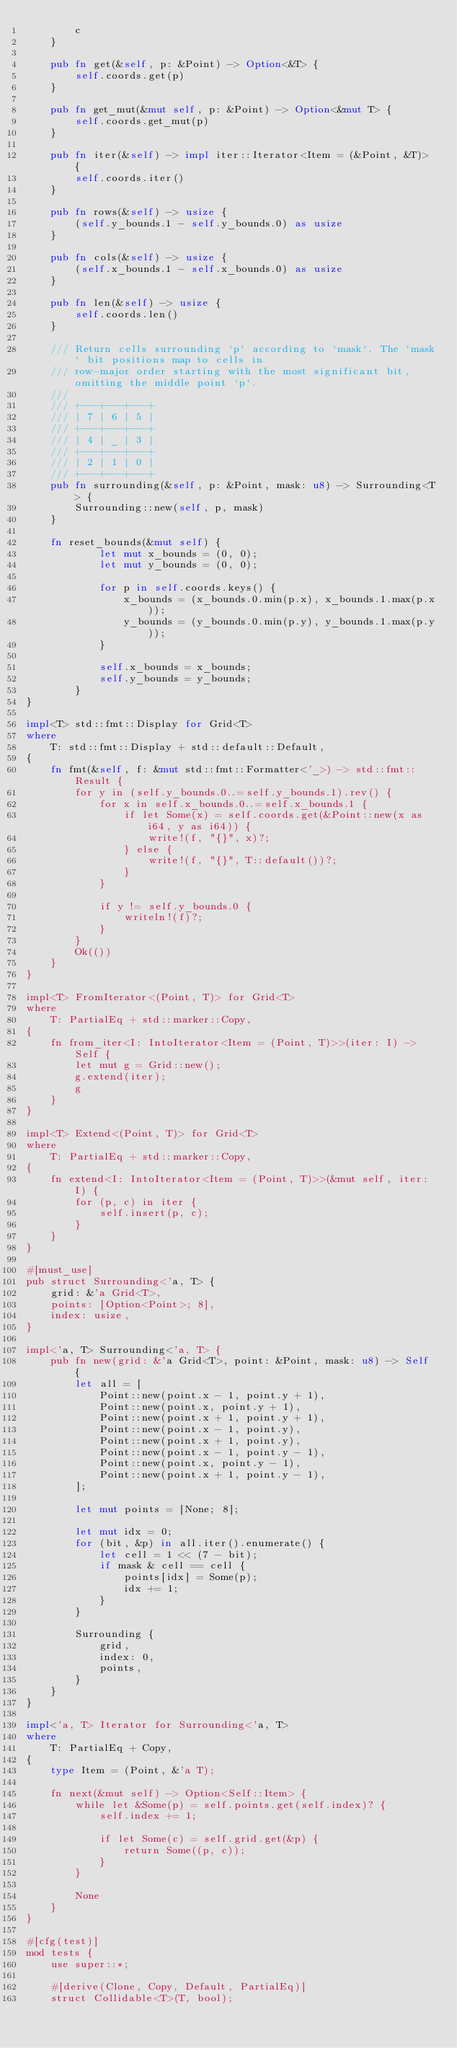<code> <loc_0><loc_0><loc_500><loc_500><_Rust_>        c
    }

    pub fn get(&self, p: &Point) -> Option<&T> {
        self.coords.get(p)
    }

    pub fn get_mut(&mut self, p: &Point) -> Option<&mut T> {
        self.coords.get_mut(p)
    }

    pub fn iter(&self) -> impl iter::Iterator<Item = (&Point, &T)> {
        self.coords.iter()
    }

    pub fn rows(&self) -> usize {
        (self.y_bounds.1 - self.y_bounds.0) as usize
    }

    pub fn cols(&self) -> usize {
        (self.x_bounds.1 - self.x_bounds.0) as usize
    }

    pub fn len(&self) -> usize {
        self.coords.len()
    }

    /// Return cells surrounding `p` according to `mask`. The `mask` bit positions map to cells in
    /// row-major order starting with the most significant bit, omitting the middle point `p`.
    ///
    /// +---+---+---+
    /// | 7 | 6 | 5 |
    /// +---+---+---+
    /// | 4 | _ | 3 |
    /// +---+---+---+
    /// | 2 | 1 | 0 |
    /// +---+---+---+
    pub fn surrounding(&self, p: &Point, mask: u8) -> Surrounding<T> {
        Surrounding::new(self, p, mask)
    }

    fn reset_bounds(&mut self) {
            let mut x_bounds = (0, 0);
            let mut y_bounds = (0, 0);

            for p in self.coords.keys() {
                x_bounds = (x_bounds.0.min(p.x), x_bounds.1.max(p.x));
                y_bounds = (y_bounds.0.min(p.y), y_bounds.1.max(p.y));
            }

            self.x_bounds = x_bounds;
            self.y_bounds = y_bounds;
        }
}

impl<T> std::fmt::Display for Grid<T>
where
    T: std::fmt::Display + std::default::Default,
{
    fn fmt(&self, f: &mut std::fmt::Formatter<'_>) -> std::fmt::Result {
        for y in (self.y_bounds.0..=self.y_bounds.1).rev() {
            for x in self.x_bounds.0..=self.x_bounds.1 {
                if let Some(x) = self.coords.get(&Point::new(x as i64, y as i64)) {
                    write!(f, "{}", x)?;
                } else {
                    write!(f, "{}", T::default())?;
                }
            }

            if y != self.y_bounds.0 {
                writeln!(f)?;
            }
        }
        Ok(())
    }
}

impl<T> FromIterator<(Point, T)> for Grid<T>
where
    T: PartialEq + std::marker::Copy,
{
    fn from_iter<I: IntoIterator<Item = (Point, T)>>(iter: I) -> Self {
        let mut g = Grid::new();
        g.extend(iter);
        g
    }
}

impl<T> Extend<(Point, T)> for Grid<T>
where
    T: PartialEq + std::marker::Copy,
{
    fn extend<I: IntoIterator<Item = (Point, T)>>(&mut self, iter: I) {
        for (p, c) in iter {
            self.insert(p, c);
        }
    }
}

#[must_use]
pub struct Surrounding<'a, T> {
    grid: &'a Grid<T>,
    points: [Option<Point>; 8],
    index: usize,
}

impl<'a, T> Surrounding<'a, T> {
    pub fn new(grid: &'a Grid<T>, point: &Point, mask: u8) -> Self {
        let all = [
            Point::new(point.x - 1, point.y + 1),
            Point::new(point.x, point.y + 1),
            Point::new(point.x + 1, point.y + 1),
            Point::new(point.x - 1, point.y),
            Point::new(point.x + 1, point.y),
            Point::new(point.x - 1, point.y - 1),
            Point::new(point.x, point.y - 1),
            Point::new(point.x + 1, point.y - 1),
        ];

        let mut points = [None; 8];

        let mut idx = 0;
        for (bit, &p) in all.iter().enumerate() {
            let cell = 1 << (7 - bit);
            if mask & cell == cell {
                points[idx] = Some(p);
                idx += 1;
            }
        }

        Surrounding {
            grid,
            index: 0,
            points,
        }
    }
}

impl<'a, T> Iterator for Surrounding<'a, T>
where
    T: PartialEq + Copy,
{
    type Item = (Point, &'a T);

    fn next(&mut self) -> Option<Self::Item> {
        while let &Some(p) = self.points.get(self.index)? {
            self.index += 1;

            if let Some(c) = self.grid.get(&p) {
                return Some((p, c));
            }
        }

        None
    }
}

#[cfg(test)]
mod tests {
    use super::*;

    #[derive(Clone, Copy, Default, PartialEq)]
    struct Collidable<T>(T, bool);
</code> 